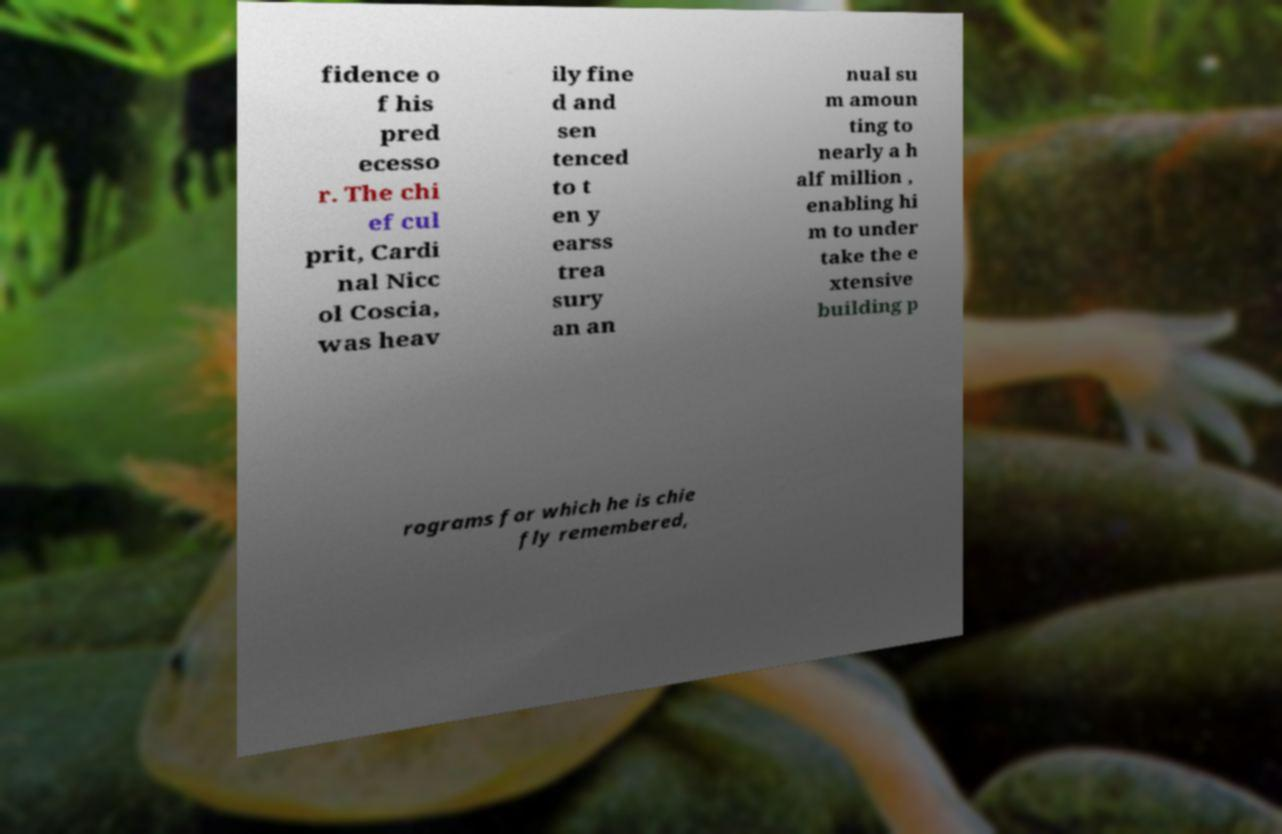Please identify and transcribe the text found in this image. fidence o f his pred ecesso r. The chi ef cul prit, Cardi nal Nicc ol Coscia, was heav ily fine d and sen tenced to t en y earss trea sury an an nual su m amoun ting to nearly a h alf million , enabling hi m to under take the e xtensive building p rograms for which he is chie fly remembered, 